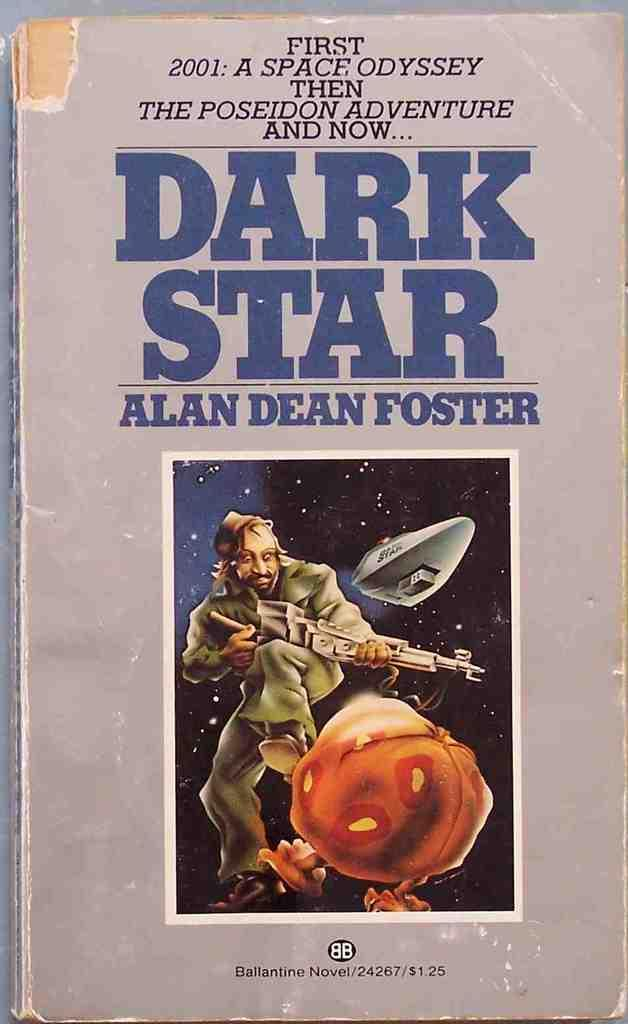<image>
Share a concise interpretation of the image provided. A book by Alan Dean Foster has a man in space holding a gun on the cover. 